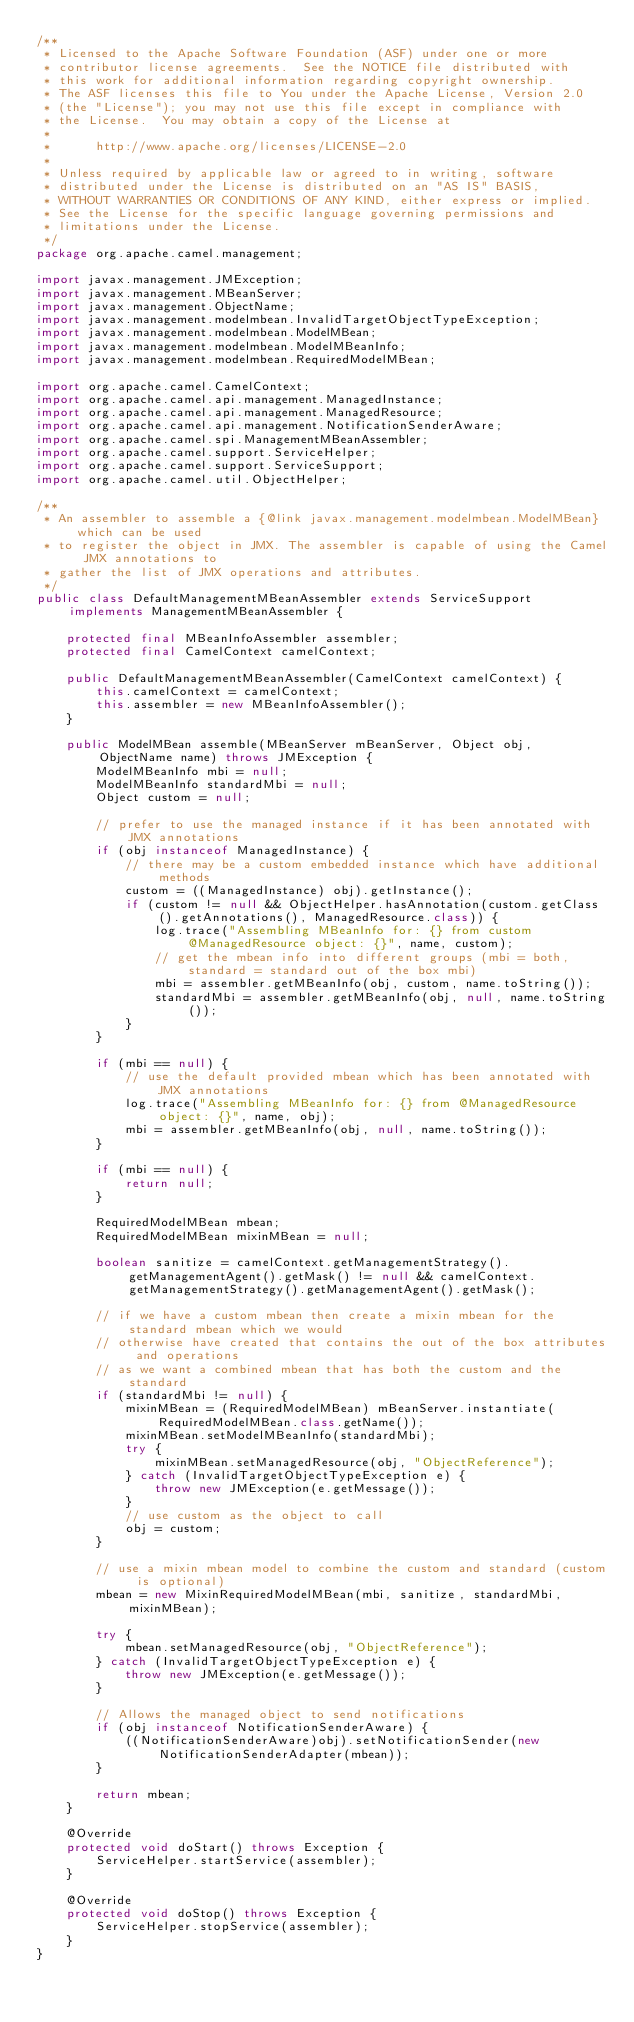Convert code to text. <code><loc_0><loc_0><loc_500><loc_500><_Java_>/**
 * Licensed to the Apache Software Foundation (ASF) under one or more
 * contributor license agreements.  See the NOTICE file distributed with
 * this work for additional information regarding copyright ownership.
 * The ASF licenses this file to You under the Apache License, Version 2.0
 * (the "License"); you may not use this file except in compliance with
 * the License.  You may obtain a copy of the License at
 *
 *      http://www.apache.org/licenses/LICENSE-2.0
 *
 * Unless required by applicable law or agreed to in writing, software
 * distributed under the License is distributed on an "AS IS" BASIS,
 * WITHOUT WARRANTIES OR CONDITIONS OF ANY KIND, either express or implied.
 * See the License for the specific language governing permissions and
 * limitations under the License.
 */
package org.apache.camel.management;

import javax.management.JMException;
import javax.management.MBeanServer;
import javax.management.ObjectName;
import javax.management.modelmbean.InvalidTargetObjectTypeException;
import javax.management.modelmbean.ModelMBean;
import javax.management.modelmbean.ModelMBeanInfo;
import javax.management.modelmbean.RequiredModelMBean;

import org.apache.camel.CamelContext;
import org.apache.camel.api.management.ManagedInstance;
import org.apache.camel.api.management.ManagedResource;
import org.apache.camel.api.management.NotificationSenderAware;
import org.apache.camel.spi.ManagementMBeanAssembler;
import org.apache.camel.support.ServiceHelper;
import org.apache.camel.support.ServiceSupport;
import org.apache.camel.util.ObjectHelper;

/**
 * An assembler to assemble a {@link javax.management.modelmbean.ModelMBean} which can be used
 * to register the object in JMX. The assembler is capable of using the Camel JMX annotations to
 * gather the list of JMX operations and attributes.
 */
public class DefaultManagementMBeanAssembler extends ServiceSupport implements ManagementMBeanAssembler {

    protected final MBeanInfoAssembler assembler;
    protected final CamelContext camelContext;

    public DefaultManagementMBeanAssembler(CamelContext camelContext) {
        this.camelContext = camelContext;
        this.assembler = new MBeanInfoAssembler();
    }

    public ModelMBean assemble(MBeanServer mBeanServer, Object obj, ObjectName name) throws JMException {
        ModelMBeanInfo mbi = null;
        ModelMBeanInfo standardMbi = null;
        Object custom = null;

        // prefer to use the managed instance if it has been annotated with JMX annotations
        if (obj instanceof ManagedInstance) {
            // there may be a custom embedded instance which have additional methods
            custom = ((ManagedInstance) obj).getInstance();
            if (custom != null && ObjectHelper.hasAnnotation(custom.getClass().getAnnotations(), ManagedResource.class)) {
                log.trace("Assembling MBeanInfo for: {} from custom @ManagedResource object: {}", name, custom);
                // get the mbean info into different groups (mbi = both, standard = standard out of the box mbi)
                mbi = assembler.getMBeanInfo(obj, custom, name.toString());
                standardMbi = assembler.getMBeanInfo(obj, null, name.toString());
            }
        }

        if (mbi == null) {
            // use the default provided mbean which has been annotated with JMX annotations
            log.trace("Assembling MBeanInfo for: {} from @ManagedResource object: {}", name, obj);
            mbi = assembler.getMBeanInfo(obj, null, name.toString());
        }

        if (mbi == null) {
            return null;
        }

        RequiredModelMBean mbean;
        RequiredModelMBean mixinMBean = null;

        boolean sanitize = camelContext.getManagementStrategy().getManagementAgent().getMask() != null && camelContext.getManagementStrategy().getManagementAgent().getMask();

        // if we have a custom mbean then create a mixin mbean for the standard mbean which we would
        // otherwise have created that contains the out of the box attributes and operations
        // as we want a combined mbean that has both the custom and the standard
        if (standardMbi != null) {
            mixinMBean = (RequiredModelMBean) mBeanServer.instantiate(RequiredModelMBean.class.getName());
            mixinMBean.setModelMBeanInfo(standardMbi);
            try {
                mixinMBean.setManagedResource(obj, "ObjectReference");
            } catch (InvalidTargetObjectTypeException e) {
                throw new JMException(e.getMessage());
            }
            // use custom as the object to call
            obj = custom;
        }

        // use a mixin mbean model to combine the custom and standard (custom is optional)
        mbean = new MixinRequiredModelMBean(mbi, sanitize, standardMbi, mixinMBean);

        try {
            mbean.setManagedResource(obj, "ObjectReference");
        } catch (InvalidTargetObjectTypeException e) {
            throw new JMException(e.getMessage());
        }

        // Allows the managed object to send notifications
        if (obj instanceof NotificationSenderAware) {
            ((NotificationSenderAware)obj).setNotificationSender(new NotificationSenderAdapter(mbean));
        }

        return mbean;
    }

    @Override
    protected void doStart() throws Exception {
        ServiceHelper.startService(assembler);
    }

    @Override
    protected void doStop() throws Exception {
        ServiceHelper.stopService(assembler);
    }
}
</code> 